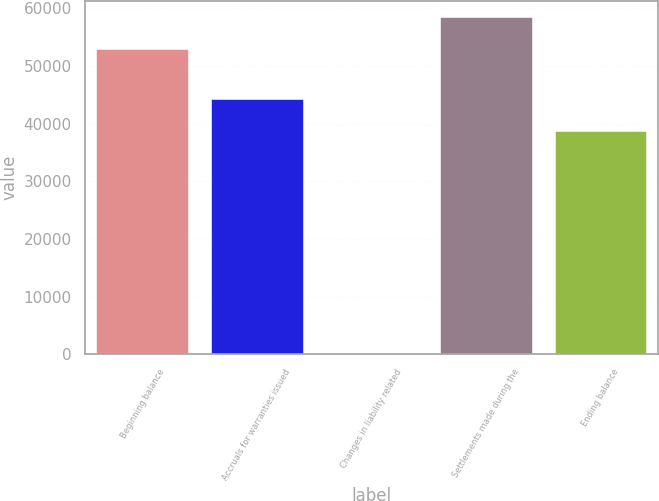Convert chart. <chart><loc_0><loc_0><loc_500><loc_500><bar_chart><fcel>Beginning balance<fcel>Accruals for warranties issued<fcel>Changes in liability related<fcel>Settlements made during the<fcel>Ending balance<nl><fcel>52838<fcel>44261.4<fcel>254<fcel>58399.4<fcel>38700<nl></chart> 